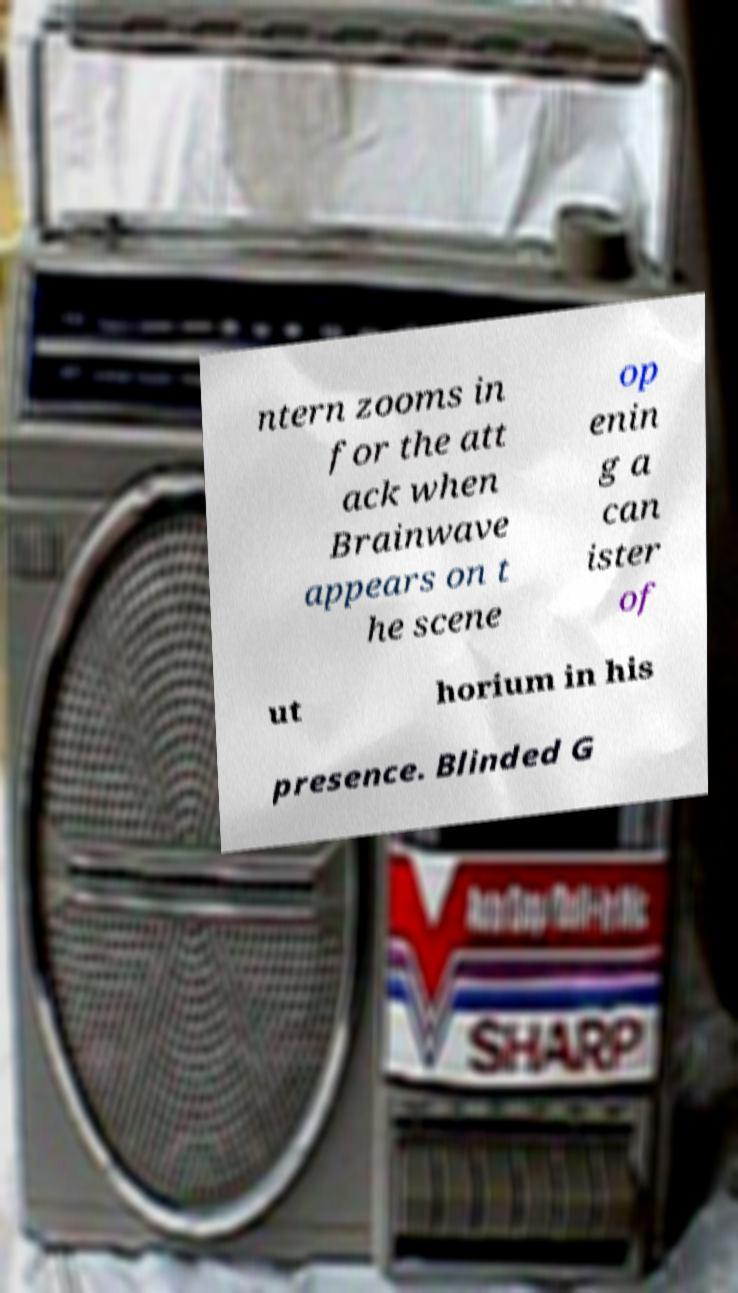Could you extract and type out the text from this image? ntern zooms in for the att ack when Brainwave appears on t he scene op enin g a can ister of ut horium in his presence. Blinded G 